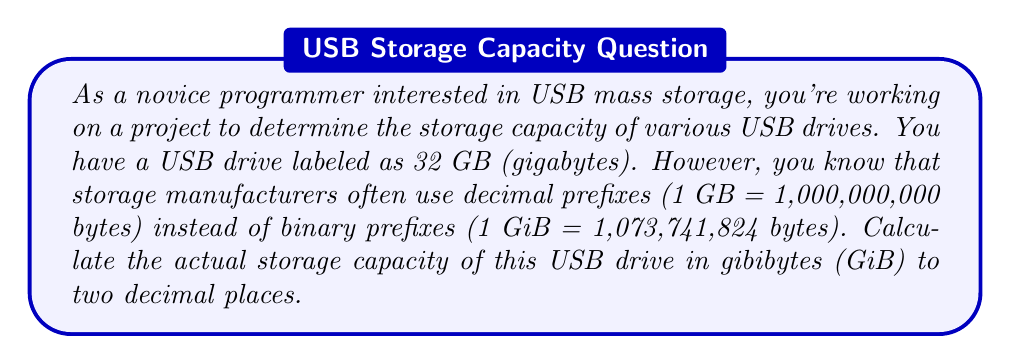Help me with this question. To solve this problem, we need to follow these steps:

1. Understand the given information:
   - The USB drive is labeled as 32 GB
   - 1 GB (decimal) = 1,000,000,000 bytes
   - 1 GiB (binary) = 1,073,741,824 bytes

2. Calculate the total number of bytes in the USB drive:
   $$32 \text{ GB} \times 1,000,000,000 \text{ bytes/GB} = 32,000,000,000 \text{ bytes}$$

3. Convert bytes to gibibytes:
   $$\text{GiB} = \frac{\text{bytes}}{1,073,741,824 \text{ bytes/GiB}}$$

   $$\text{GiB} = \frac{32,000,000,000}{1,073,741,824}$$

4. Perform the division:
   $$\text{GiB} = 29.8023223876953125$$

5. Round to two decimal places:
   $$\text{GiB} \approx 29.80 \text{ GiB}$$

This calculation shows that the actual storage capacity of the USB drive in binary units (GiB) is less than the advertised capacity in decimal units (GB).
Answer: The actual storage capacity of the 32 GB USB drive is approximately 29.80 GiB. 